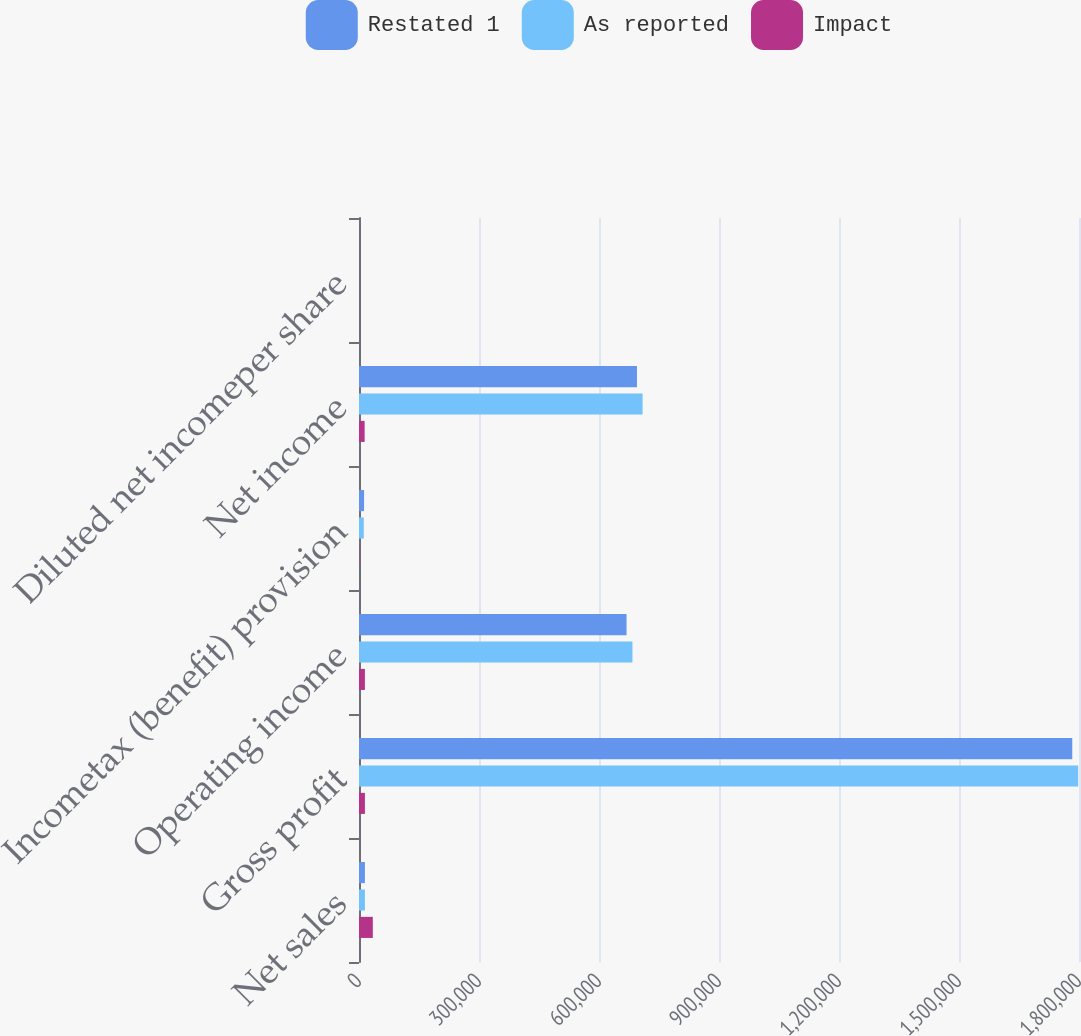Convert chart. <chart><loc_0><loc_0><loc_500><loc_500><stacked_bar_chart><ecel><fcel>Net sales<fcel>Gross profit<fcel>Operating income<fcel>Incometax (benefit) provision<fcel>Net income<fcel>Diluted net incomeper share<nl><fcel>Restated 1<fcel>14777<fcel>1.78316e+06<fcel>668860<fcel>12661<fcel>694955<fcel>3.68<nl><fcel>As reported<fcel>14777<fcel>1.79794e+06<fcel>683637<fcel>11936<fcel>709007<fcel>3.76<nl><fcel>Impact<fcel>34556<fcel>14777<fcel>14777<fcel>725<fcel>14052<fcel>0.08<nl></chart> 